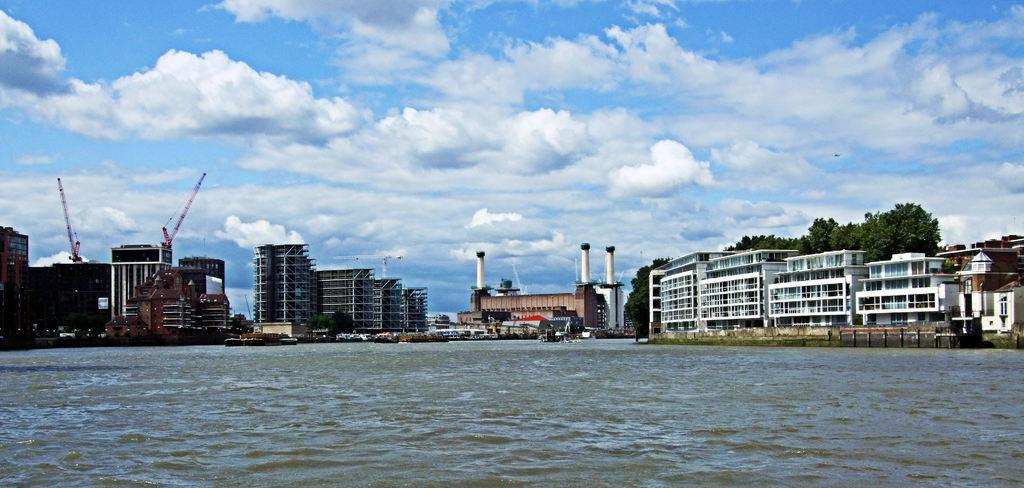What type of structures can be seen in the image? There are buildings in the image. What equipment is present at the construction site? Construction cranes are present in the image. What mode of transportation can be seen on the road? Motor vehicles are visible on the road. What type of watercraft is on the water in the image? Ships are on the water in the image. What type of vegetation is present in the image? Trees are present in the image. What type of industrial feature can be seen on the buildings? Chimneys are visible in the image. What is visible in the background of the image? The sky is visible in the background of the image. What type of weather can be inferred from the sky? Clouds are present in the sky, suggesting that it might be partly cloudy. Where is the sofa located in the image? There is no sofa present in the image. What type of discussion is taking place between the construction cranes in the image? Construction cranes are inanimate objects and cannot engage in discussions. 